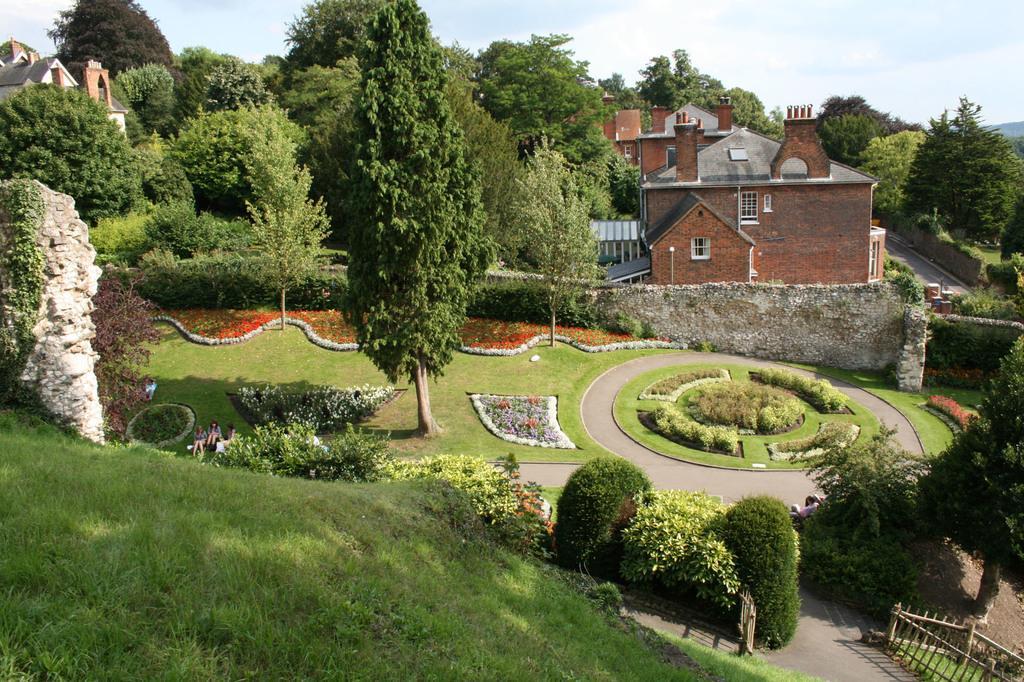Can you describe this image briefly? In this image, we can see some houses, plants, trees, people. We can see the ground with some grass. We can also see the fence and the sky with clouds. 